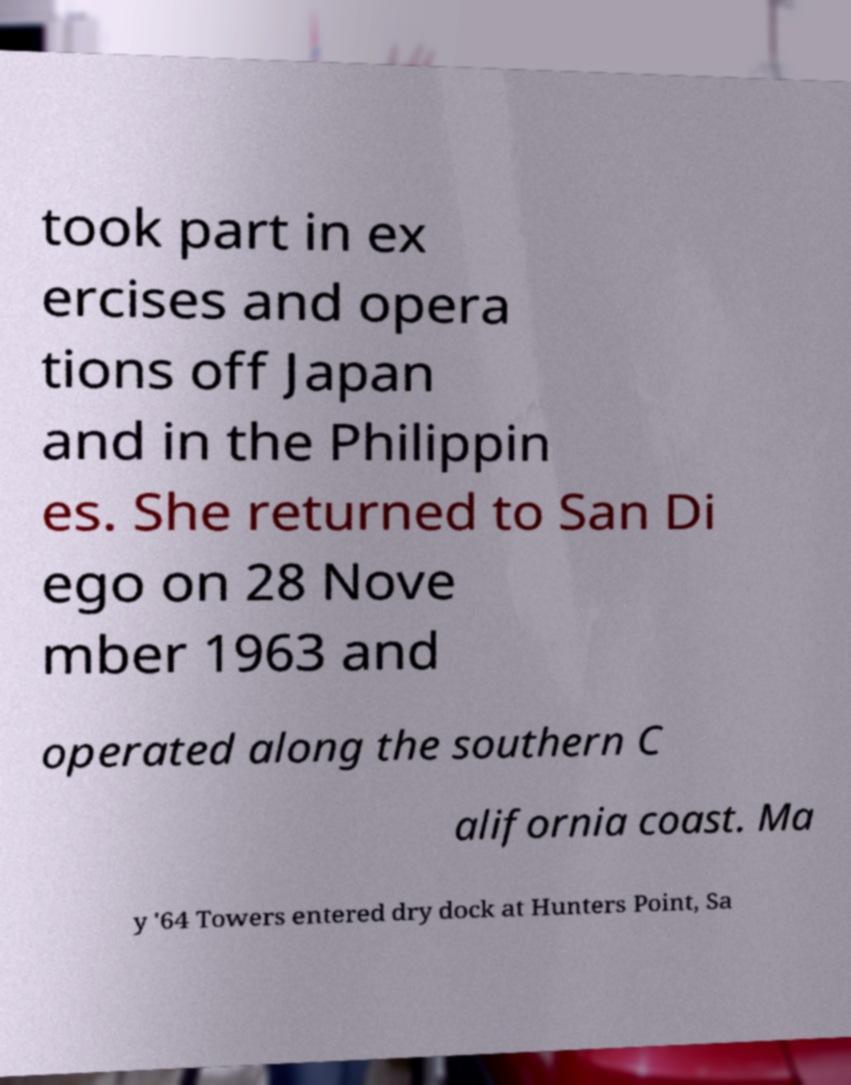Could you extract and type out the text from this image? took part in ex ercises and opera tions off Japan and in the Philippin es. She returned to San Di ego on 28 Nove mber 1963 and operated along the southern C alifornia coast. Ma y '64 Towers entered dry dock at Hunters Point, Sa 